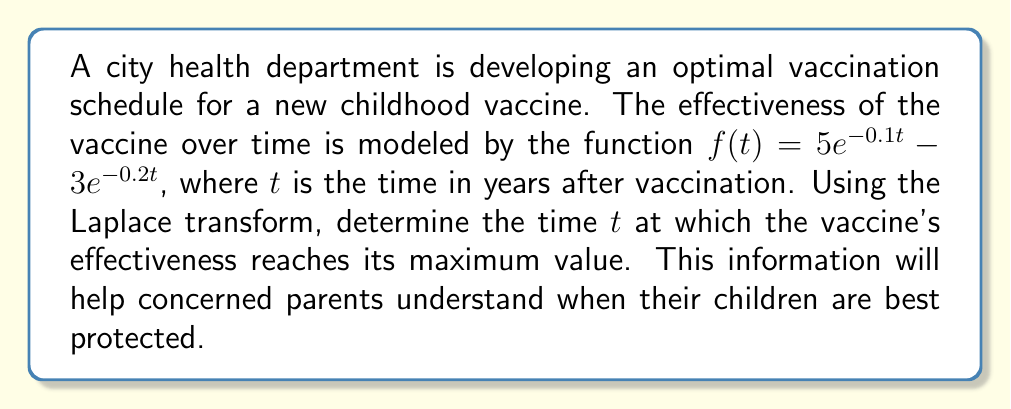Give your solution to this math problem. To solve this problem, we'll use the following steps:

1) First, we need to find the Laplace transform of $f(t)$:

   $\mathcal{L}\{f(t)\} = F(s) = \mathcal{L}\{5e^{-0.1t} - 3e^{-0.2t}\}$
   
   $F(s) = \frac{5}{s+0.1} - \frac{3}{s+0.2}$

2) To find the maximum value, we need to find where the derivative of $f(t)$ equals zero. In the s-domain, this is equivalent to multiplying $F(s)$ by $s$:

   $sF(s) = \frac{5s}{s+0.1} - \frac{3s}{s+0.2}$

3) Now, we need to find the inverse Laplace transform of $sF(s)$:

   $\mathcal{L}^{-1}\{sF(s)\} = f'(t) = 5(0.1)e^{-0.1t} - 3(0.2)e^{-0.2t}$
   
   $f'(t) = 0.5e^{-0.1t} - 0.6e^{-0.2t}$

4) Set $f'(t) = 0$ and solve for $t$:

   $0.5e^{-0.1t} - 0.6e^{-0.2t} = 0$
   
   $0.5e^{-0.1t} = 0.6e^{-0.2t}$
   
   $\frac{5}{6} = e^{0.1t}$
   
   $\ln(\frac{5}{6}) = 0.1t$
   
   $t = \frac{\ln(\frac{5}{6})}{0.1} \approx 1.8325$ years

5) To confirm this is a maximum, we can check the second derivative:

   $f''(t) = -0.05e^{-0.1t} + 0.12e^{-0.2t}$
   
   At $t \approx 1.8325$, $f''(t) < 0$, confirming a local maximum.

Therefore, the vaccine's effectiveness reaches its maximum value approximately 1.8325 years after vaccination.
Answer: The vaccine's effectiveness reaches its maximum value at $t \approx 1.8325$ years after vaccination. 